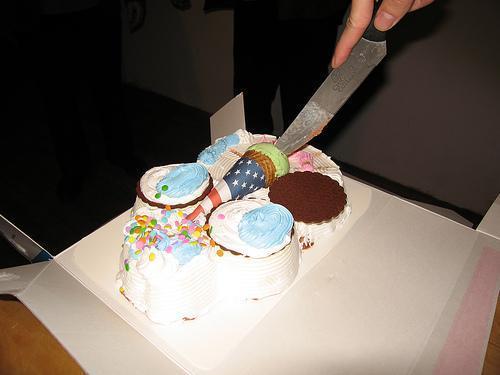How many cakes are there?
Give a very brief answer. 1. How many cakes are in the photo?
Give a very brief answer. 1. How many knives are in the photo?
Give a very brief answer. 1. 